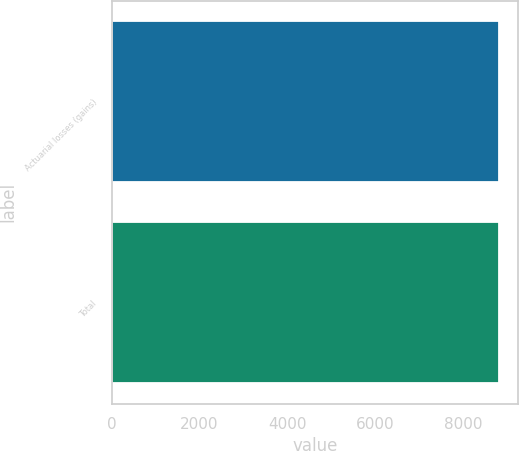Convert chart to OTSL. <chart><loc_0><loc_0><loc_500><loc_500><bar_chart><fcel>Actuarial losses (gains)<fcel>Total<nl><fcel>8814<fcel>8814.1<nl></chart> 